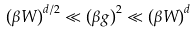<formula> <loc_0><loc_0><loc_500><loc_500>\left ( \beta W \right ) ^ { d / 2 } \ll \left ( \beta g \right ) ^ { 2 } \ll \left ( \beta W \right ) ^ { d }</formula> 